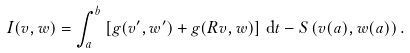Convert formula to latex. <formula><loc_0><loc_0><loc_500><loc_500>I ( v , w ) = \int _ { a } ^ { b } \left [ g ( v ^ { \prime } , w ^ { \prime } ) + g ( R v , w ) \right ] \, \mathrm d t - S \left ( v ( a ) , w ( a ) \right ) .</formula> 